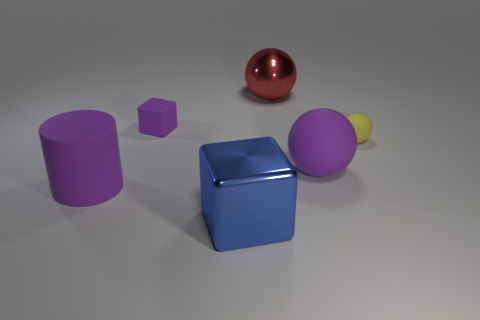Is the material of the cube in front of the small sphere the same as the big cylinder?
Provide a short and direct response. No. Are there an equal number of purple cylinders that are behind the small sphere and big purple rubber objects to the right of the big blue cube?
Keep it short and to the point. No. There is a thing that is behind the big matte sphere and right of the red shiny sphere; what shape is it?
Provide a short and direct response. Sphere. There is a small yellow rubber object; how many tiny matte things are behind it?
Give a very brief answer. 1. What number of other objects are the same shape as the tiny purple rubber thing?
Ensure brevity in your answer.  1. Is the number of large blue metallic balls less than the number of purple balls?
Provide a succinct answer. Yes. There is a purple thing that is both in front of the yellow thing and on the right side of the purple matte cylinder; what is its size?
Provide a succinct answer. Large. How big is the purple cylinder on the left side of the metallic object behind the purple rubber object in front of the large rubber sphere?
Keep it short and to the point. Large. What is the size of the cylinder?
Offer a terse response. Large. Are there any other things that are made of the same material as the red ball?
Provide a succinct answer. Yes. 